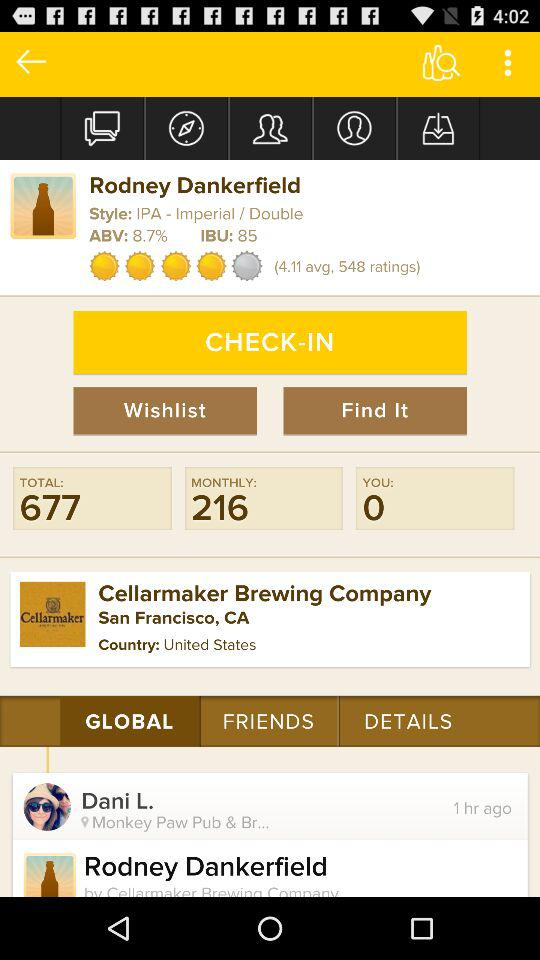What is the location of the "Cellarmaker Brewing Company"? The location of the "Cellarmaker Brewing Company" is San Francisco, CA, United States. 